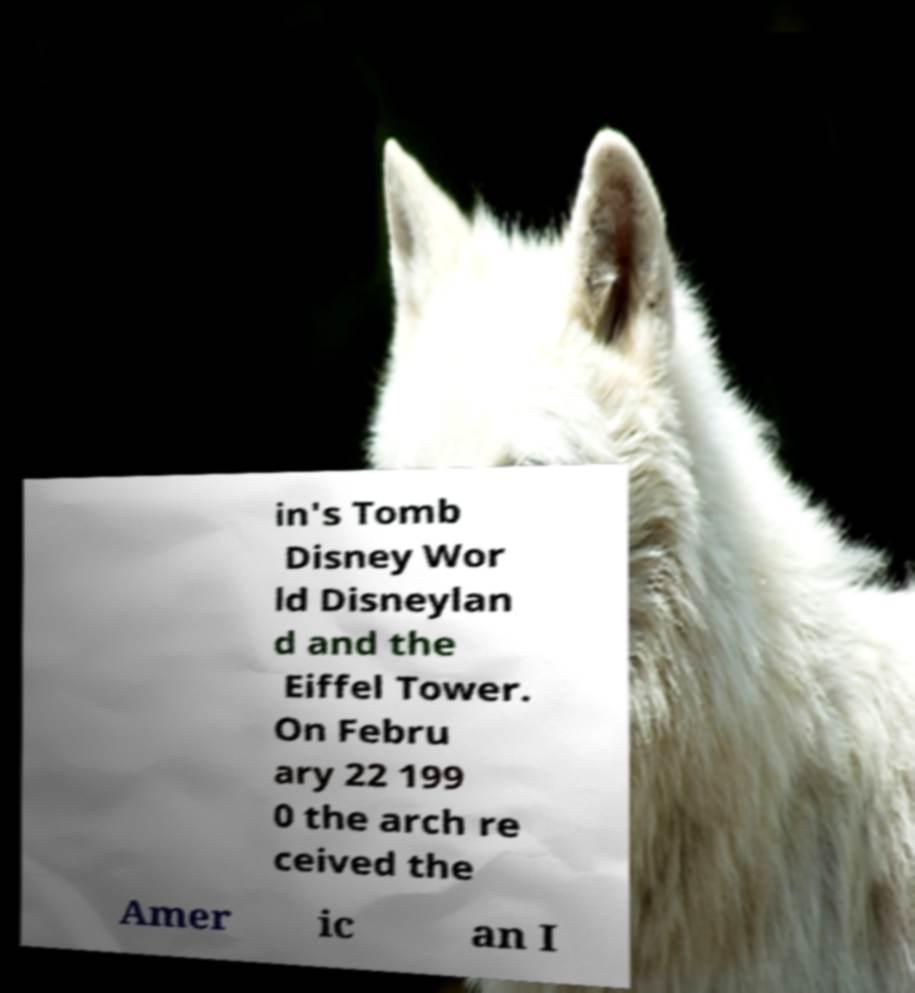I need the written content from this picture converted into text. Can you do that? in's Tomb Disney Wor ld Disneylan d and the Eiffel Tower. On Febru ary 22 199 0 the arch re ceived the Amer ic an I 